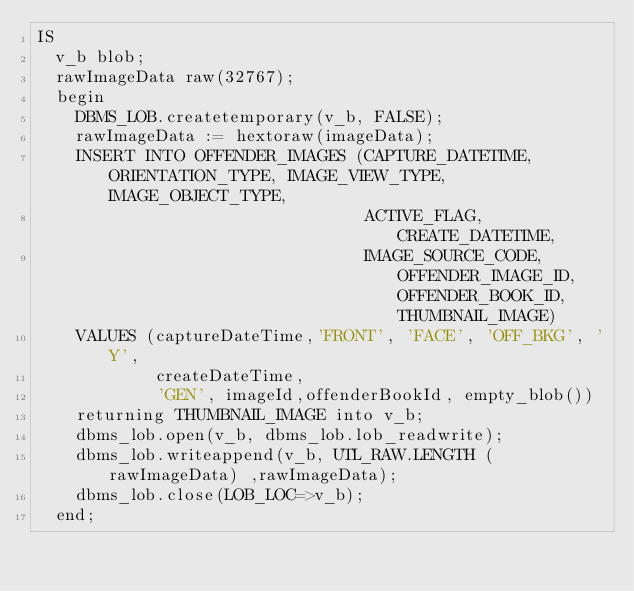<code> <loc_0><loc_0><loc_500><loc_500><_SQL_>IS
  v_b blob;
  rawImageData raw(32767);
  begin
    DBMS_LOB.createtemporary(v_b, FALSE);
    rawImageData := hextoraw(imageData);
    INSERT INTO OFFENDER_IMAGES (CAPTURE_DATETIME, ORIENTATION_TYPE, IMAGE_VIEW_TYPE,  IMAGE_OBJECT_TYPE,
                                 ACTIVE_FLAG, CREATE_DATETIME,
                                 IMAGE_SOURCE_CODE, OFFENDER_IMAGE_ID, OFFENDER_BOOK_ID, THUMBNAIL_IMAGE)
    VALUES (captureDateTime,'FRONT', 'FACE', 'OFF_BKG', 'Y',
            createDateTime,
            'GEN', imageId,offenderBookId, empty_blob())
    returning THUMBNAIL_IMAGE into v_b;
    dbms_lob.open(v_b, dbms_lob.lob_readwrite);
    dbms_lob.writeappend(v_b, UTL_RAW.LENGTH (rawImageData) ,rawImageData);
    dbms_lob.close(LOB_LOC=>v_b);
  end;</code> 